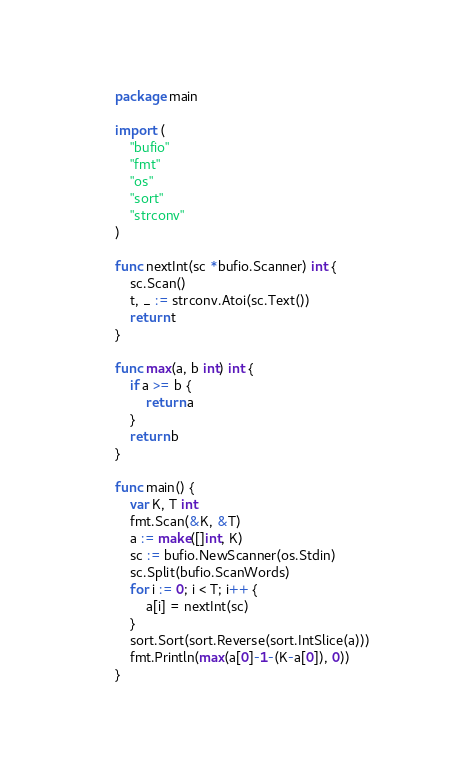<code> <loc_0><loc_0><loc_500><loc_500><_Go_>package main

import (
	"bufio"
	"fmt"
	"os"
	"sort"
	"strconv"
)

func nextInt(sc *bufio.Scanner) int {
	sc.Scan()
	t, _ := strconv.Atoi(sc.Text())
	return t
}

func max(a, b int) int {
	if a >= b {
		return a
	}
	return b
}

func main() {
	var K, T int
	fmt.Scan(&K, &T)
	a := make([]int, K)
	sc := bufio.NewScanner(os.Stdin)
	sc.Split(bufio.ScanWords)
	for i := 0; i < T; i++ {
		a[i] = nextInt(sc)
	}
	sort.Sort(sort.Reverse(sort.IntSlice(a)))
	fmt.Println(max(a[0]-1-(K-a[0]), 0))
}
</code> 